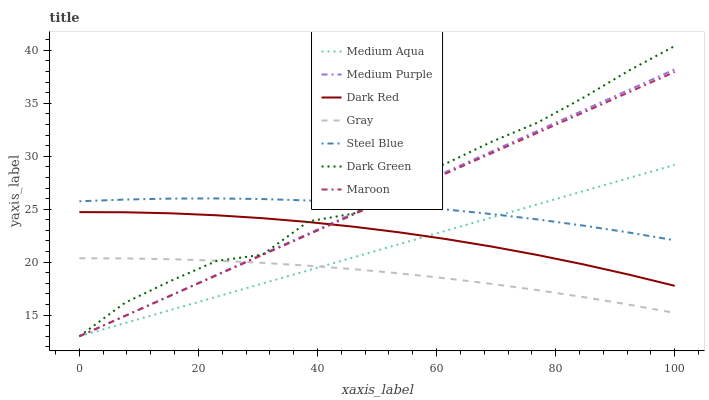Does Gray have the minimum area under the curve?
Answer yes or no. Yes. Does Dark Green have the maximum area under the curve?
Answer yes or no. Yes. Does Dark Red have the minimum area under the curve?
Answer yes or no. No. Does Dark Red have the maximum area under the curve?
Answer yes or no. No. Is Maroon the smoothest?
Answer yes or no. Yes. Is Dark Green the roughest?
Answer yes or no. Yes. Is Dark Red the smoothest?
Answer yes or no. No. Is Dark Red the roughest?
Answer yes or no. No. Does Maroon have the lowest value?
Answer yes or no. Yes. Does Dark Red have the lowest value?
Answer yes or no. No. Does Dark Green have the highest value?
Answer yes or no. Yes. Does Dark Red have the highest value?
Answer yes or no. No. Is Dark Red less than Steel Blue?
Answer yes or no. Yes. Is Steel Blue greater than Dark Red?
Answer yes or no. Yes. Does Medium Aqua intersect Medium Purple?
Answer yes or no. Yes. Is Medium Aqua less than Medium Purple?
Answer yes or no. No. Is Medium Aqua greater than Medium Purple?
Answer yes or no. No. Does Dark Red intersect Steel Blue?
Answer yes or no. No. 